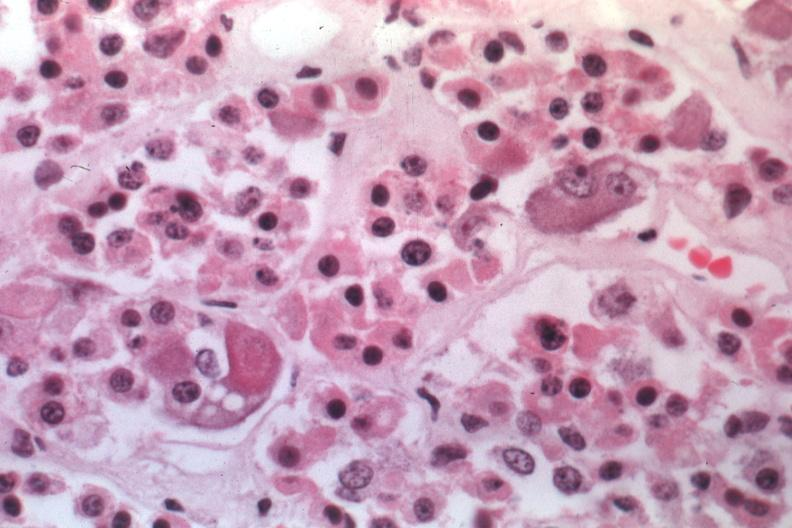what is present?
Answer the question using a single word or phrase. Endocrine 